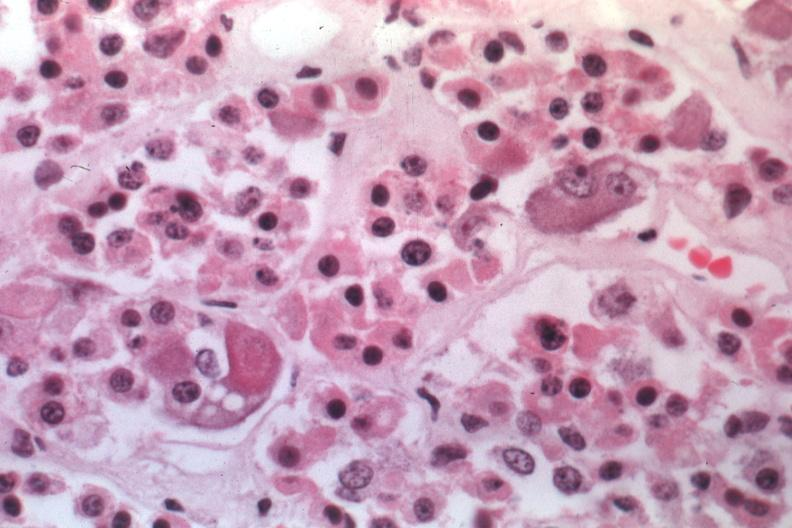what is present?
Answer the question using a single word or phrase. Endocrine 